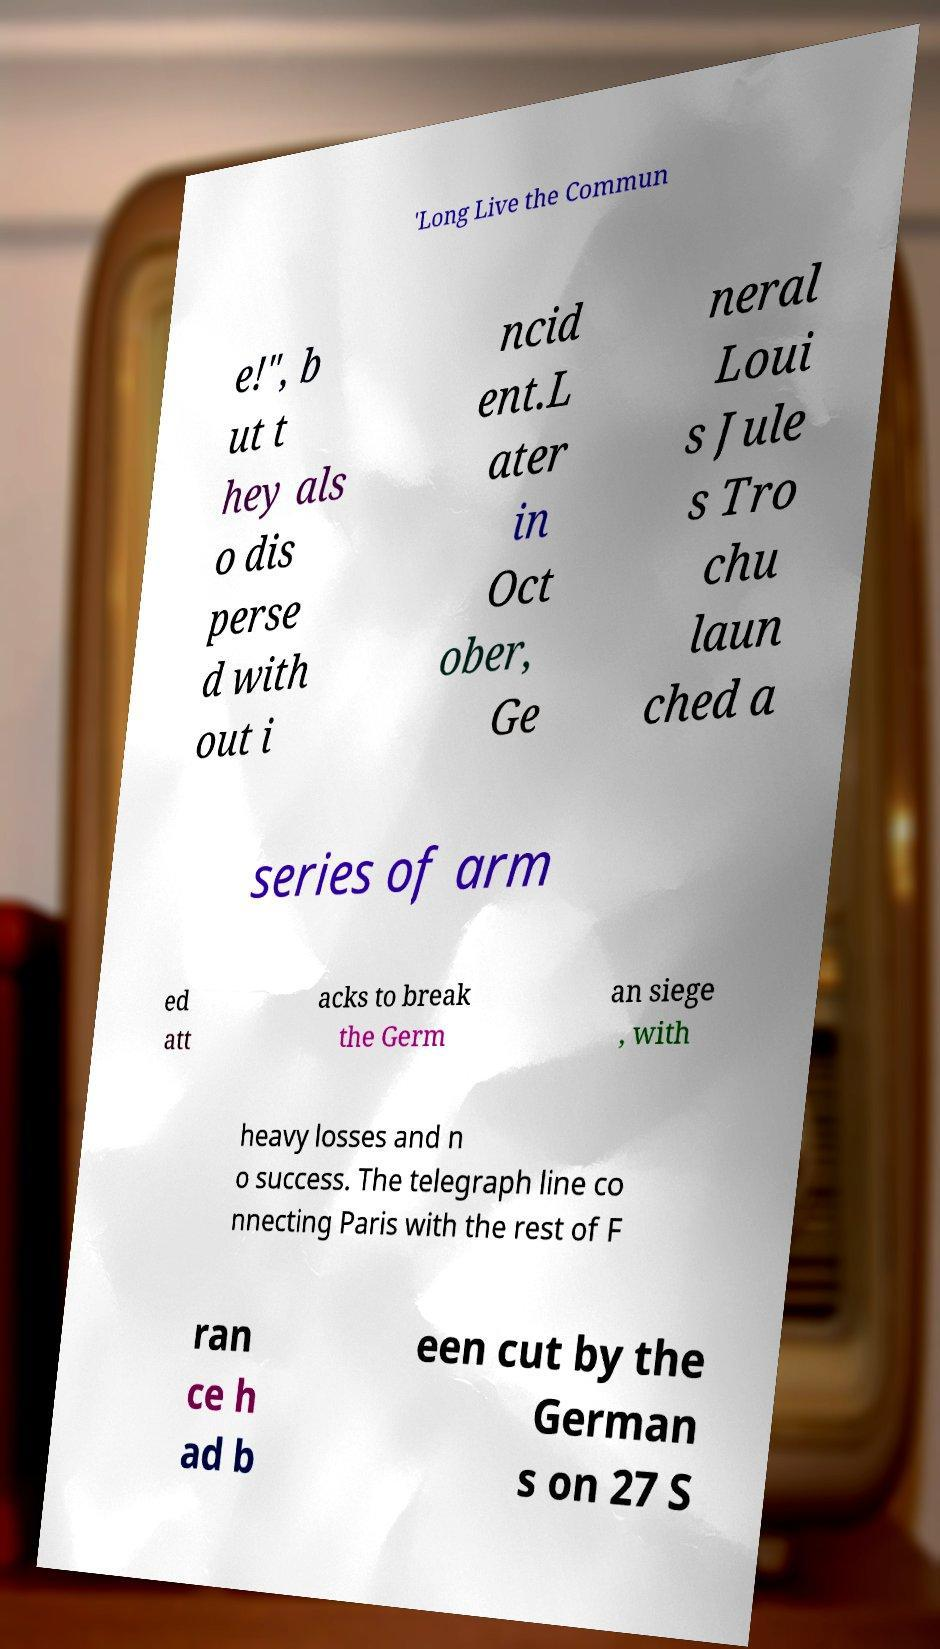There's text embedded in this image that I need extracted. Can you transcribe it verbatim? 'Long Live the Commun e!", b ut t hey als o dis perse d with out i ncid ent.L ater in Oct ober, Ge neral Loui s Jule s Tro chu laun ched a series of arm ed att acks to break the Germ an siege , with heavy losses and n o success. The telegraph line co nnecting Paris with the rest of F ran ce h ad b een cut by the German s on 27 S 